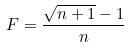Convert formula to latex. <formula><loc_0><loc_0><loc_500><loc_500>F = \frac { \sqrt { n + 1 } - 1 } { n }</formula> 